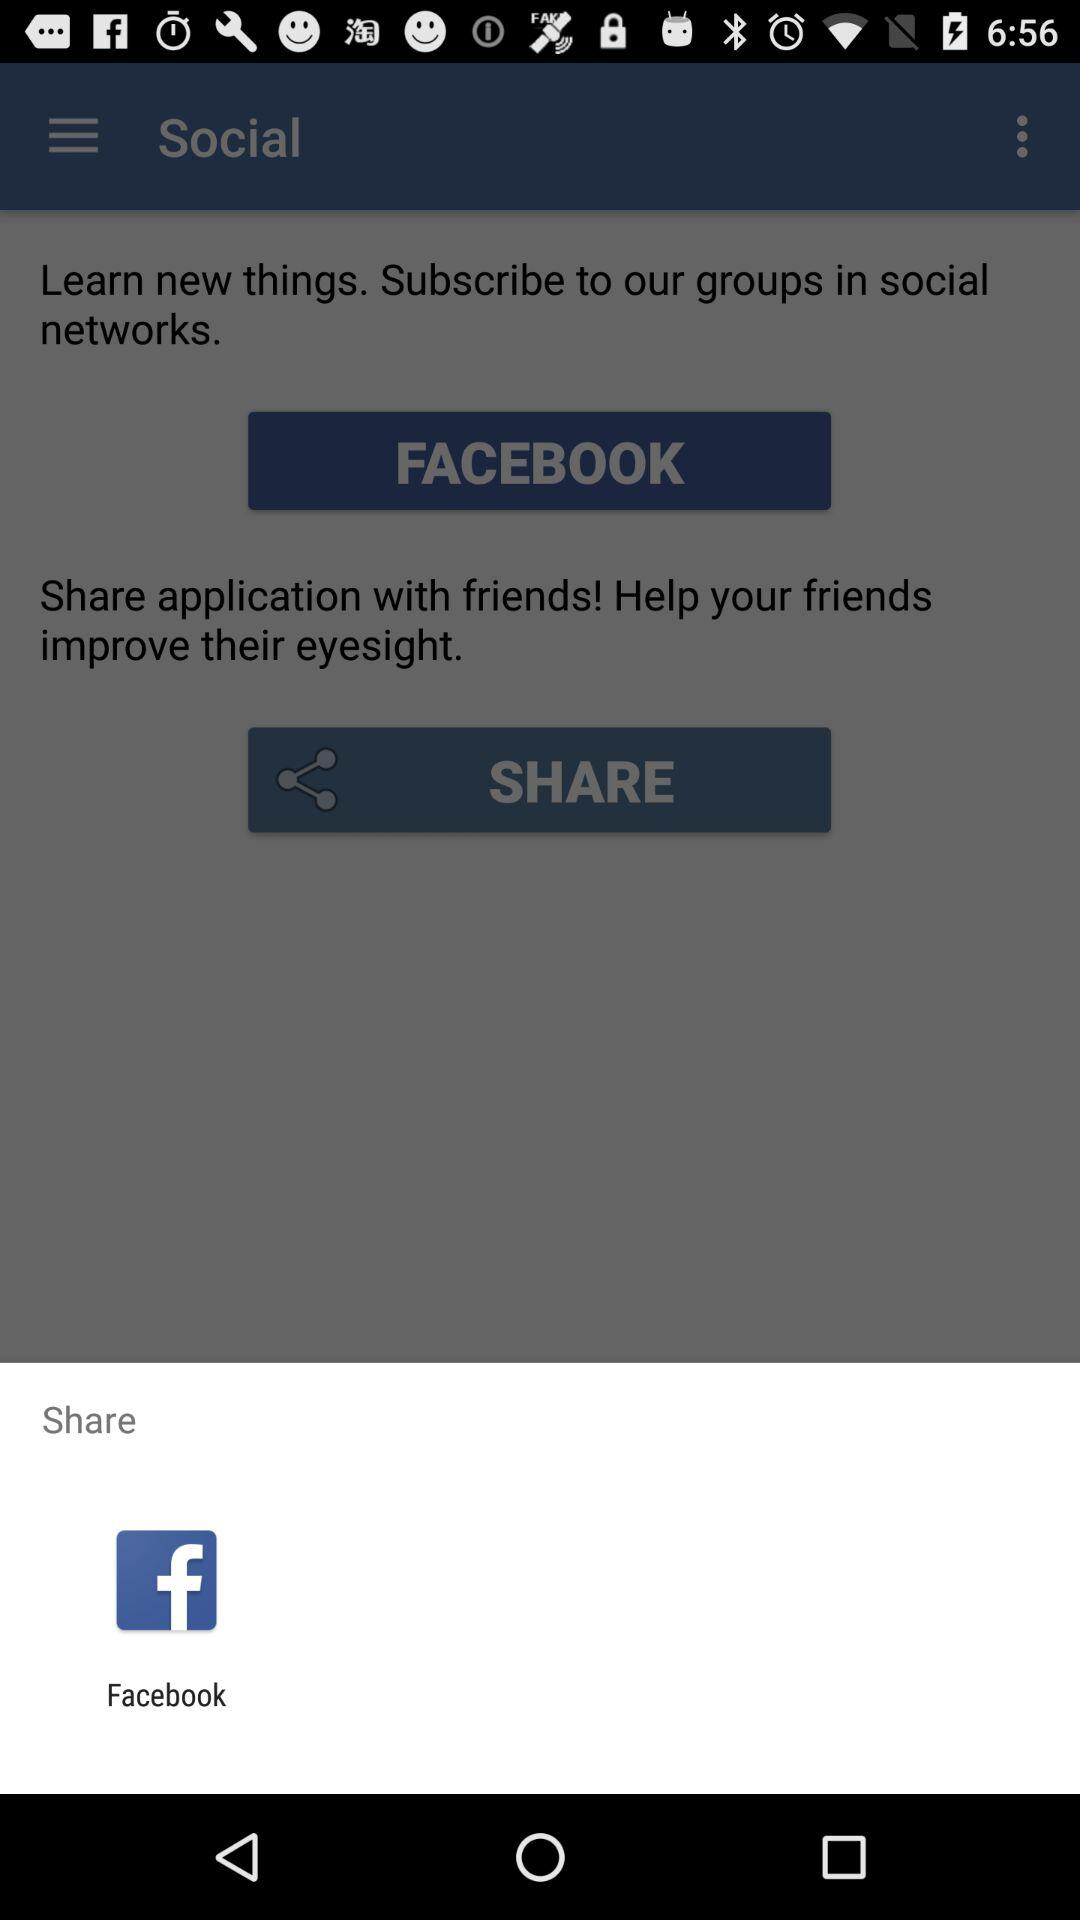Through what application can we share? You can share through "Facebook". 